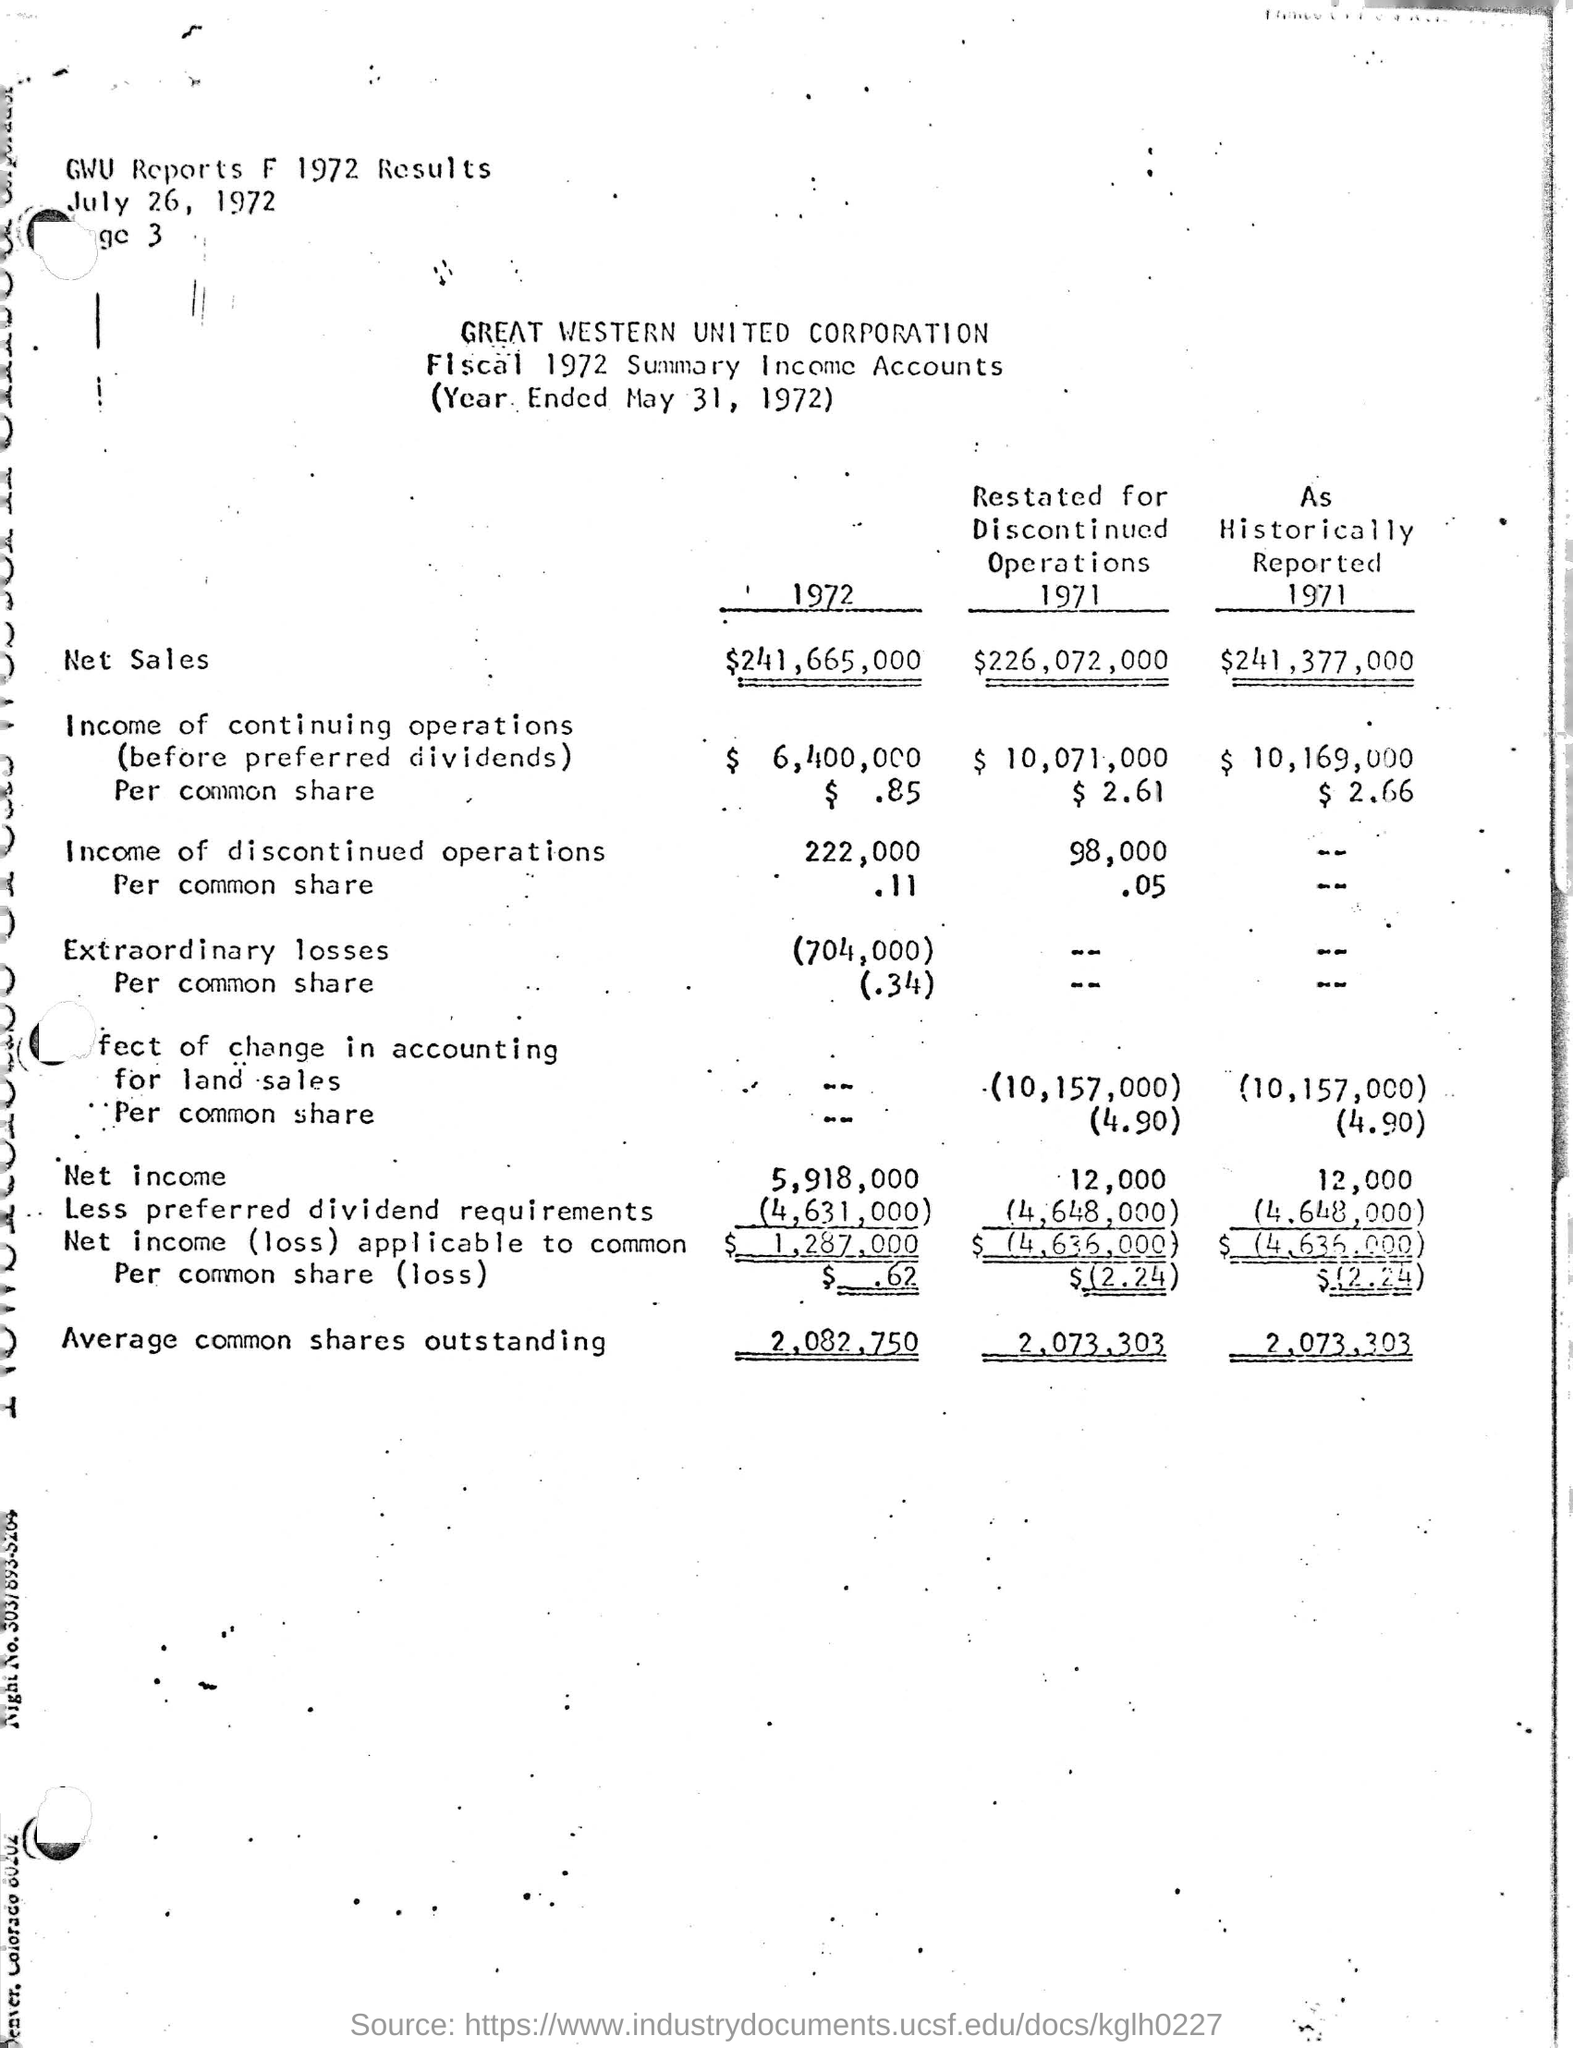What is the name of the corporation mentioned ?
Give a very brief answer. Great Western United. What is the date mentioned at the top of the page ?
Make the answer very short. July 26, 1972. What is the net sales amount for the year 1972 ?
Your answer should be very brief. $241,665,000. What is the amount for average common shares outstanding for the year 1972 ?
Offer a very short reply. 2,082,750. What is the net income amount for the year 1972 ?
Ensure brevity in your answer.  5,918,000. 